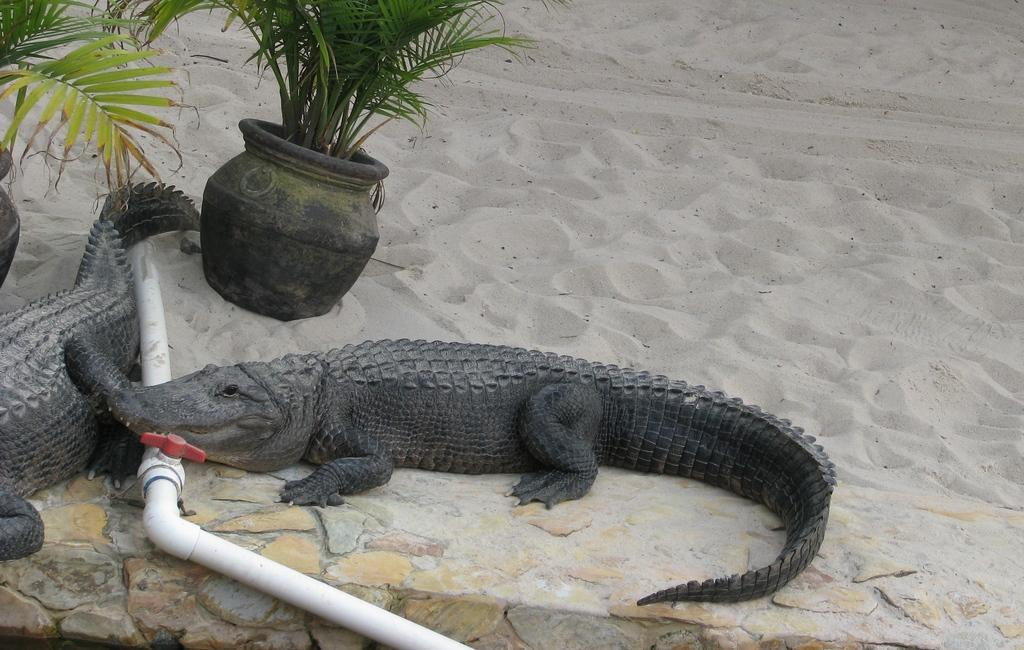What can be found on the left side of the image? There are two potted plants on the left side of the image. What animals are present in the image? There are two crocodiles on a sand surface in the image. What is the color of the pipe near the sand surface? The pipe near the sand surface is white. What type of surface is visible in the background of the image? There is a sand surface visible in the background of the image. What type of theory is being discussed by the crocodiles in the image? There is no indication in the image that the crocodiles are discussing any theories. What color are the jeans worn by the potted plants in the image? The potted plants are not wearing jeans, as they are inanimate objects. 